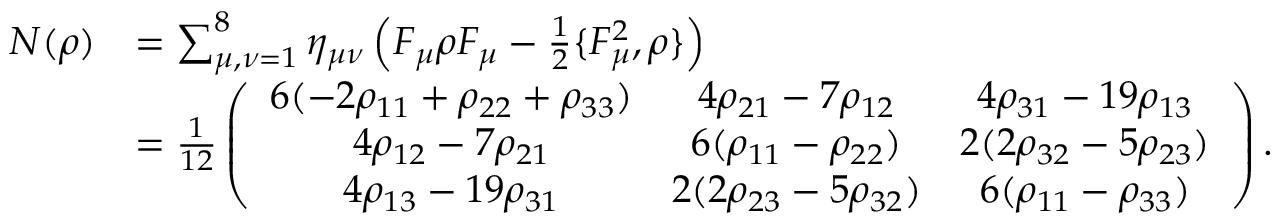<formula> <loc_0><loc_0><loc_500><loc_500>\begin{array} { r l } { N ( \rho ) } & { = \sum _ { \mu , \nu = 1 } ^ { 8 } \eta _ { \mu \nu } \left ( F _ { \mu } \rho F _ { \mu } - \frac { 1 } { 2 } \{ F _ { \mu } ^ { 2 } , \rho \} \right ) } \\ & { = \frac { 1 } { 1 2 } \left ( \begin{array} { c c c } { 6 ( - 2 \rho _ { 1 1 } + \rho _ { 2 2 } + \rho _ { 3 3 } ) } & { 4 \rho _ { 2 1 } - 7 \rho _ { 1 2 } } & { 4 \rho _ { 3 1 } - 1 9 \rho _ { 1 3 } } \\ { 4 \rho _ { 1 2 } - 7 \rho _ { 2 1 } } & { 6 ( \rho _ { 1 1 } - \rho _ { 2 2 } ) } & { 2 ( 2 \rho _ { 3 2 } - 5 \rho _ { 2 3 } ) } \\ { 4 \rho _ { 1 3 } - 1 9 \rho _ { 3 1 } } & { 2 ( 2 \rho _ { 2 3 } - 5 \rho _ { 3 2 } ) } & { 6 ( \rho _ { 1 1 } - \rho _ { 3 3 } ) } \end{array} \right ) . } \end{array}</formula> 